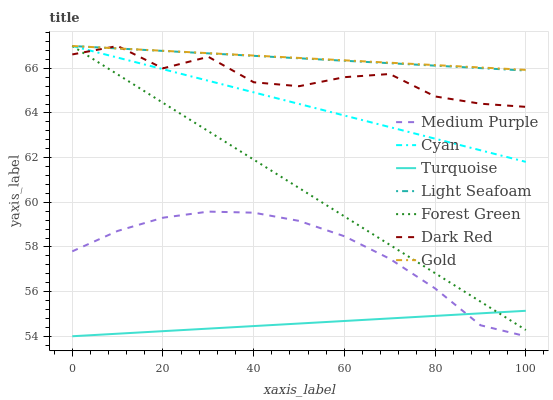Does Turquoise have the minimum area under the curve?
Answer yes or no. Yes. Does Gold have the maximum area under the curve?
Answer yes or no. Yes. Does Dark Red have the minimum area under the curve?
Answer yes or no. No. Does Dark Red have the maximum area under the curve?
Answer yes or no. No. Is Forest Green the smoothest?
Answer yes or no. Yes. Is Dark Red the roughest?
Answer yes or no. Yes. Is Gold the smoothest?
Answer yes or no. No. Is Gold the roughest?
Answer yes or no. No. Does Turquoise have the lowest value?
Answer yes or no. Yes. Does Dark Red have the lowest value?
Answer yes or no. No. Does Light Seafoam have the highest value?
Answer yes or no. Yes. Does Medium Purple have the highest value?
Answer yes or no. No. Is Turquoise less than Light Seafoam?
Answer yes or no. Yes. Is Cyan greater than Turquoise?
Answer yes or no. Yes. Does Forest Green intersect Turquoise?
Answer yes or no. Yes. Is Forest Green less than Turquoise?
Answer yes or no. No. Is Forest Green greater than Turquoise?
Answer yes or no. No. Does Turquoise intersect Light Seafoam?
Answer yes or no. No. 